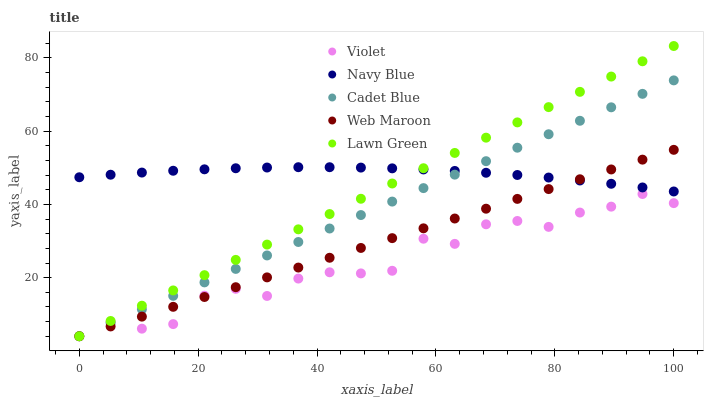Does Violet have the minimum area under the curve?
Answer yes or no. Yes. Does Navy Blue have the maximum area under the curve?
Answer yes or no. Yes. Does Cadet Blue have the minimum area under the curve?
Answer yes or no. No. Does Cadet Blue have the maximum area under the curve?
Answer yes or no. No. Is Web Maroon the smoothest?
Answer yes or no. Yes. Is Violet the roughest?
Answer yes or no. Yes. Is Cadet Blue the smoothest?
Answer yes or no. No. Is Cadet Blue the roughest?
Answer yes or no. No. Does Cadet Blue have the lowest value?
Answer yes or no. Yes. Does Lawn Green have the highest value?
Answer yes or no. Yes. Does Cadet Blue have the highest value?
Answer yes or no. No. Is Violet less than Navy Blue?
Answer yes or no. Yes. Is Navy Blue greater than Violet?
Answer yes or no. Yes. Does Cadet Blue intersect Lawn Green?
Answer yes or no. Yes. Is Cadet Blue less than Lawn Green?
Answer yes or no. No. Is Cadet Blue greater than Lawn Green?
Answer yes or no. No. Does Violet intersect Navy Blue?
Answer yes or no. No. 